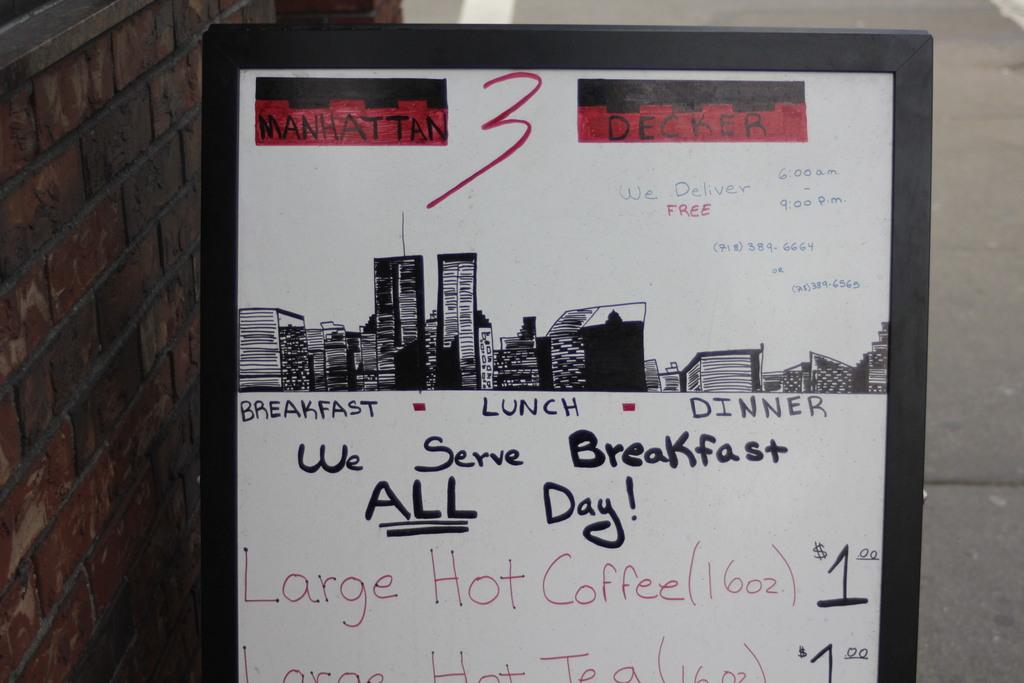How much does a large hot coffee cost?
Offer a very short reply. $1.00. Is breakfast served all day?
Your answer should be very brief. Yes. 